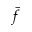Convert formula to latex. <formula><loc_0><loc_0><loc_500><loc_500>\bar { f }</formula> 